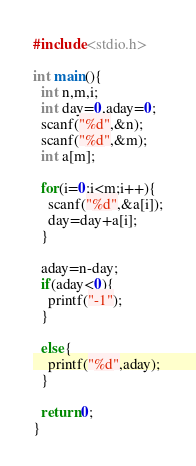<code> <loc_0><loc_0><loc_500><loc_500><_C_>#include<stdio.h>
 
int main(){
  int n,m,i;
  int day=0,aday=0;
  scanf("%d",&n);
  scanf("%d",&m);
  int a[m];
  
  for(i=0;i<m;i++){
    scanf("%d",&a[i]);
    day=day+a[i];
  }
  
  aday=n-day;
  if(aday<0){
    printf("-1");
  }
  
  else{
    printf("%d",aday);
  }
  
  return 0;
}</code> 